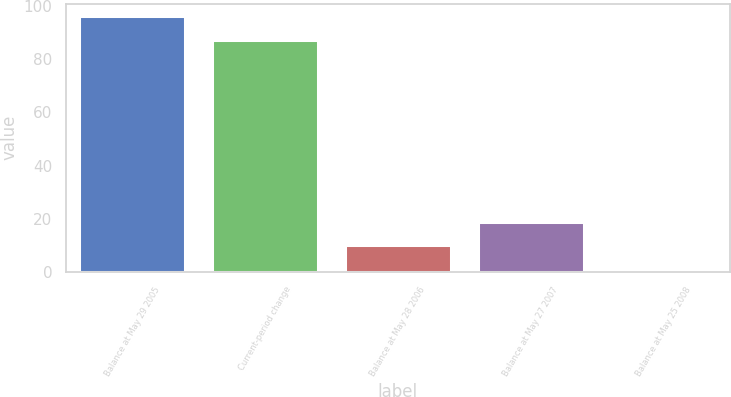<chart> <loc_0><loc_0><loc_500><loc_500><bar_chart><fcel>Balance at May 29 2005<fcel>Current-period change<fcel>Balance at May 28 2006<fcel>Balance at May 27 2007<fcel>Balance at May 25 2008<nl><fcel>96.09<fcel>87.2<fcel>9.99<fcel>18.88<fcel>1.1<nl></chart> 